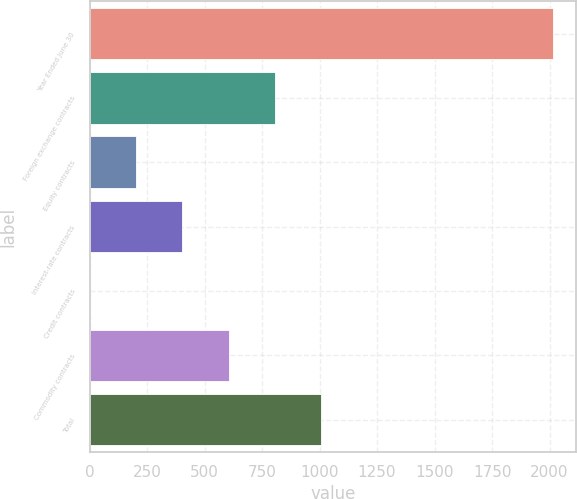Convert chart to OTSL. <chart><loc_0><loc_0><loc_500><loc_500><bar_chart><fcel>Year Ended June 30<fcel>Foreign exchange contracts<fcel>Equity contracts<fcel>Interest-rate contracts<fcel>Credit contracts<fcel>Commodity contracts<fcel>Total<nl><fcel>2015<fcel>806.6<fcel>202.4<fcel>403.8<fcel>1<fcel>605.2<fcel>1008<nl></chart> 